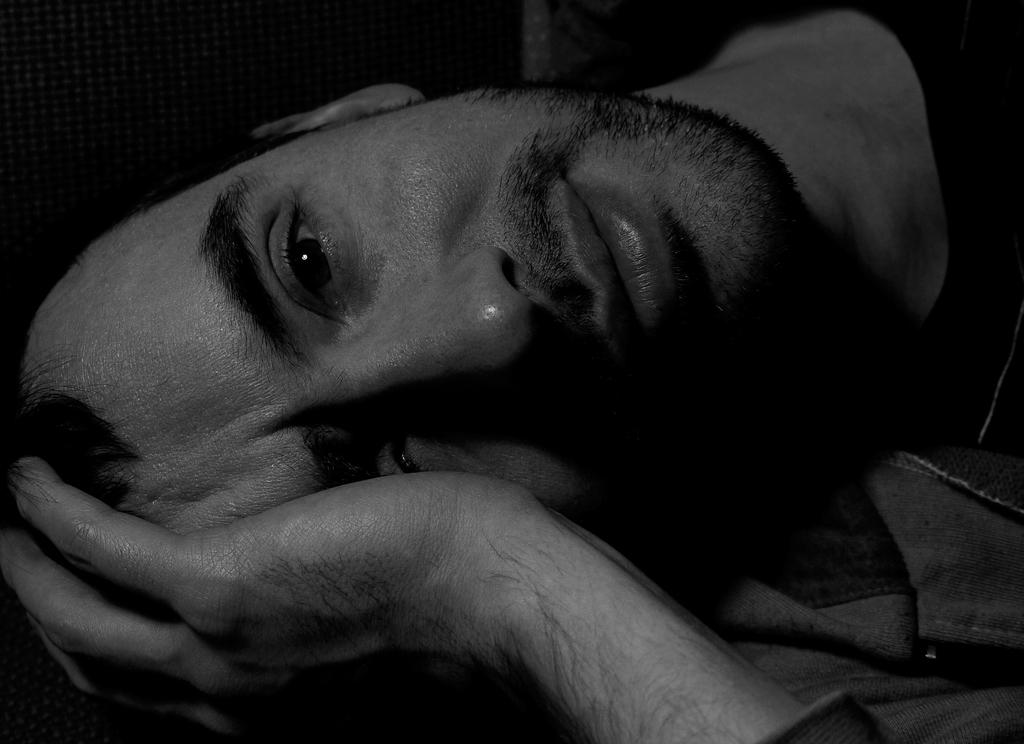What is the person in the image doing? The person is laying down in the image. What type of clothing is the person wearing? The person is wearing a hoodie. What is the color scheme of the image? The image is black and white. How many battles are depicted in the image? There are no battles depicted in the image; it features a person laying down while wearing a hoodie in a black and white setting. 